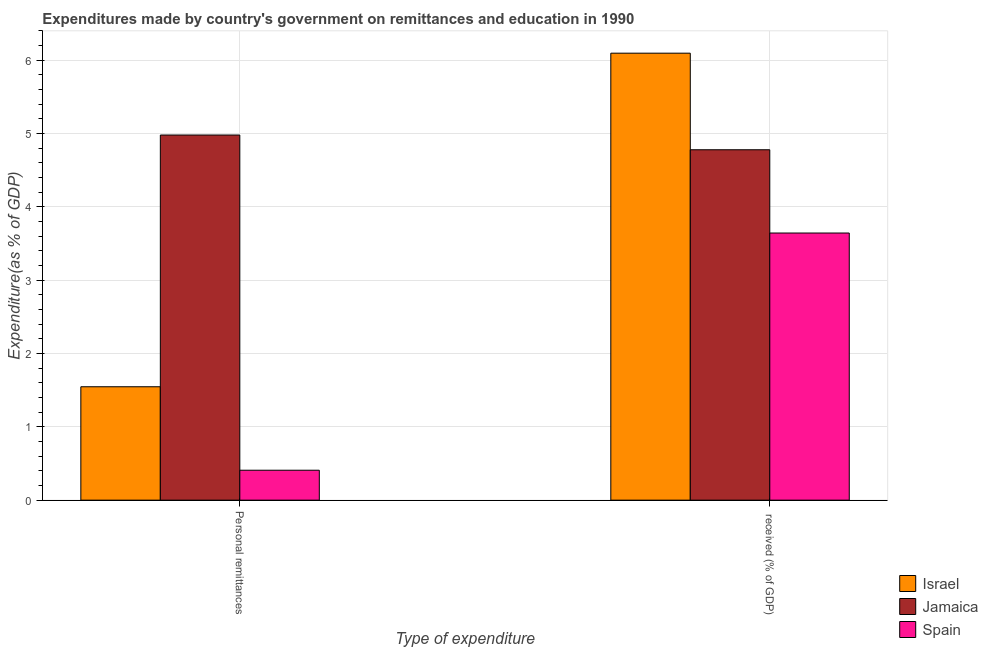How many different coloured bars are there?
Your response must be concise. 3. How many bars are there on the 1st tick from the left?
Provide a short and direct response. 3. What is the label of the 1st group of bars from the left?
Make the answer very short. Personal remittances. What is the expenditure in personal remittances in Spain?
Your response must be concise. 0.41. Across all countries, what is the maximum expenditure in personal remittances?
Make the answer very short. 4.98. Across all countries, what is the minimum expenditure in education?
Keep it short and to the point. 3.64. In which country was the expenditure in education maximum?
Ensure brevity in your answer.  Israel. In which country was the expenditure in personal remittances minimum?
Your answer should be compact. Spain. What is the total expenditure in personal remittances in the graph?
Offer a very short reply. 6.94. What is the difference between the expenditure in personal remittances in Israel and that in Spain?
Keep it short and to the point. 1.14. What is the difference between the expenditure in personal remittances in Jamaica and the expenditure in education in Israel?
Ensure brevity in your answer.  -1.12. What is the average expenditure in education per country?
Keep it short and to the point. 4.84. What is the difference between the expenditure in education and expenditure in personal remittances in Israel?
Offer a terse response. 4.55. In how many countries, is the expenditure in education greater than 2.8 %?
Give a very brief answer. 3. What is the ratio of the expenditure in education in Israel to that in Jamaica?
Ensure brevity in your answer.  1.28. In how many countries, is the expenditure in education greater than the average expenditure in education taken over all countries?
Keep it short and to the point. 1. How many bars are there?
Your response must be concise. 6. Does the graph contain any zero values?
Ensure brevity in your answer.  No. What is the title of the graph?
Make the answer very short. Expenditures made by country's government on remittances and education in 1990. Does "Lao PDR" appear as one of the legend labels in the graph?
Ensure brevity in your answer.  No. What is the label or title of the X-axis?
Provide a succinct answer. Type of expenditure. What is the label or title of the Y-axis?
Your answer should be very brief. Expenditure(as % of GDP). What is the Expenditure(as % of GDP) in Israel in Personal remittances?
Provide a succinct answer. 1.55. What is the Expenditure(as % of GDP) in Jamaica in Personal remittances?
Offer a terse response. 4.98. What is the Expenditure(as % of GDP) of Spain in Personal remittances?
Offer a terse response. 0.41. What is the Expenditure(as % of GDP) of Israel in  received (% of GDP)?
Your answer should be very brief. 6.1. What is the Expenditure(as % of GDP) of Jamaica in  received (% of GDP)?
Give a very brief answer. 4.78. What is the Expenditure(as % of GDP) in Spain in  received (% of GDP)?
Make the answer very short. 3.64. Across all Type of expenditure, what is the maximum Expenditure(as % of GDP) of Israel?
Keep it short and to the point. 6.1. Across all Type of expenditure, what is the maximum Expenditure(as % of GDP) in Jamaica?
Provide a succinct answer. 4.98. Across all Type of expenditure, what is the maximum Expenditure(as % of GDP) of Spain?
Keep it short and to the point. 3.64. Across all Type of expenditure, what is the minimum Expenditure(as % of GDP) of Israel?
Offer a terse response. 1.55. Across all Type of expenditure, what is the minimum Expenditure(as % of GDP) of Jamaica?
Provide a short and direct response. 4.78. Across all Type of expenditure, what is the minimum Expenditure(as % of GDP) in Spain?
Ensure brevity in your answer.  0.41. What is the total Expenditure(as % of GDP) in Israel in the graph?
Provide a succinct answer. 7.64. What is the total Expenditure(as % of GDP) in Jamaica in the graph?
Offer a terse response. 9.76. What is the total Expenditure(as % of GDP) in Spain in the graph?
Make the answer very short. 4.05. What is the difference between the Expenditure(as % of GDP) in Israel in Personal remittances and that in  received (% of GDP)?
Offer a very short reply. -4.55. What is the difference between the Expenditure(as % of GDP) in Jamaica in Personal remittances and that in  received (% of GDP)?
Your answer should be compact. 0.2. What is the difference between the Expenditure(as % of GDP) in Spain in Personal remittances and that in  received (% of GDP)?
Your response must be concise. -3.24. What is the difference between the Expenditure(as % of GDP) in Israel in Personal remittances and the Expenditure(as % of GDP) in Jamaica in  received (% of GDP)?
Provide a short and direct response. -3.23. What is the difference between the Expenditure(as % of GDP) in Israel in Personal remittances and the Expenditure(as % of GDP) in Spain in  received (% of GDP)?
Provide a succinct answer. -2.1. What is the difference between the Expenditure(as % of GDP) of Jamaica in Personal remittances and the Expenditure(as % of GDP) of Spain in  received (% of GDP)?
Ensure brevity in your answer.  1.34. What is the average Expenditure(as % of GDP) in Israel per Type of expenditure?
Keep it short and to the point. 3.82. What is the average Expenditure(as % of GDP) in Jamaica per Type of expenditure?
Provide a succinct answer. 4.88. What is the average Expenditure(as % of GDP) of Spain per Type of expenditure?
Make the answer very short. 2.03. What is the difference between the Expenditure(as % of GDP) of Israel and Expenditure(as % of GDP) of Jamaica in Personal remittances?
Your answer should be very brief. -3.43. What is the difference between the Expenditure(as % of GDP) of Israel and Expenditure(as % of GDP) of Spain in Personal remittances?
Ensure brevity in your answer.  1.14. What is the difference between the Expenditure(as % of GDP) in Jamaica and Expenditure(as % of GDP) in Spain in Personal remittances?
Offer a very short reply. 4.57. What is the difference between the Expenditure(as % of GDP) of Israel and Expenditure(as % of GDP) of Jamaica in  received (% of GDP)?
Provide a short and direct response. 1.32. What is the difference between the Expenditure(as % of GDP) in Israel and Expenditure(as % of GDP) in Spain in  received (% of GDP)?
Your response must be concise. 2.45. What is the difference between the Expenditure(as % of GDP) of Jamaica and Expenditure(as % of GDP) of Spain in  received (% of GDP)?
Keep it short and to the point. 1.14. What is the ratio of the Expenditure(as % of GDP) of Israel in Personal remittances to that in  received (% of GDP)?
Offer a very short reply. 0.25. What is the ratio of the Expenditure(as % of GDP) of Jamaica in Personal remittances to that in  received (% of GDP)?
Ensure brevity in your answer.  1.04. What is the ratio of the Expenditure(as % of GDP) in Spain in Personal remittances to that in  received (% of GDP)?
Your answer should be compact. 0.11. What is the difference between the highest and the second highest Expenditure(as % of GDP) of Israel?
Your answer should be compact. 4.55. What is the difference between the highest and the second highest Expenditure(as % of GDP) of Jamaica?
Give a very brief answer. 0.2. What is the difference between the highest and the second highest Expenditure(as % of GDP) of Spain?
Offer a terse response. 3.24. What is the difference between the highest and the lowest Expenditure(as % of GDP) of Israel?
Give a very brief answer. 4.55. What is the difference between the highest and the lowest Expenditure(as % of GDP) in Jamaica?
Make the answer very short. 0.2. What is the difference between the highest and the lowest Expenditure(as % of GDP) in Spain?
Your response must be concise. 3.24. 